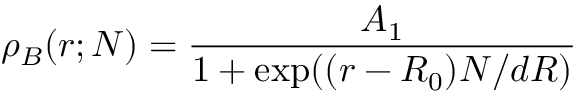<formula> <loc_0><loc_0><loc_500><loc_500>\rho _ { B } ( r ; N ) = \frac { A _ { 1 } } { 1 + e x p ( ( r - R _ { 0 } ) N / d R ) }</formula> 